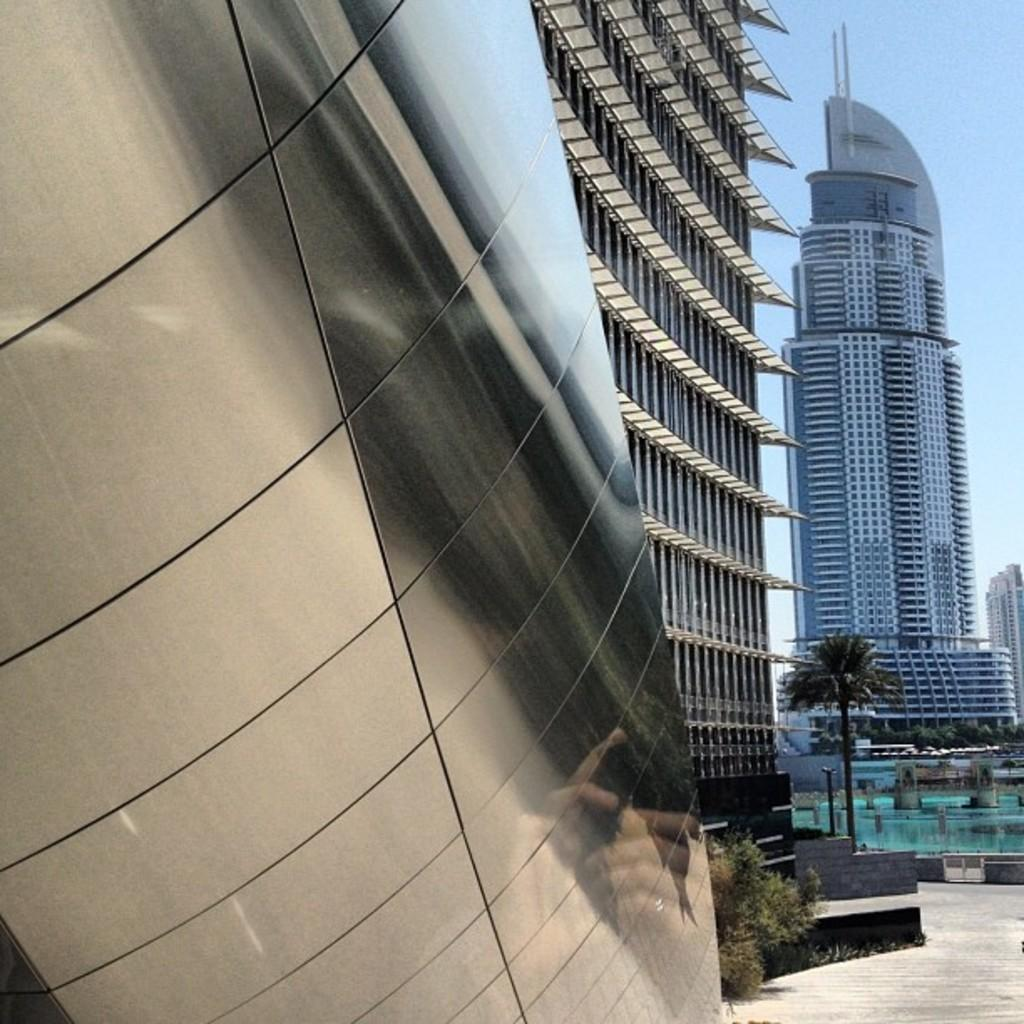What type of structures can be seen in the image? There are buildings in the image. What type of vegetation is present in the image? There are trees in the image. How many cats are sitting on the buildings in the image? There are no cats present in the image; it only features buildings and trees. What historical events are depicted in the image? The image does not depict any historical events; it only shows buildings and trees. 